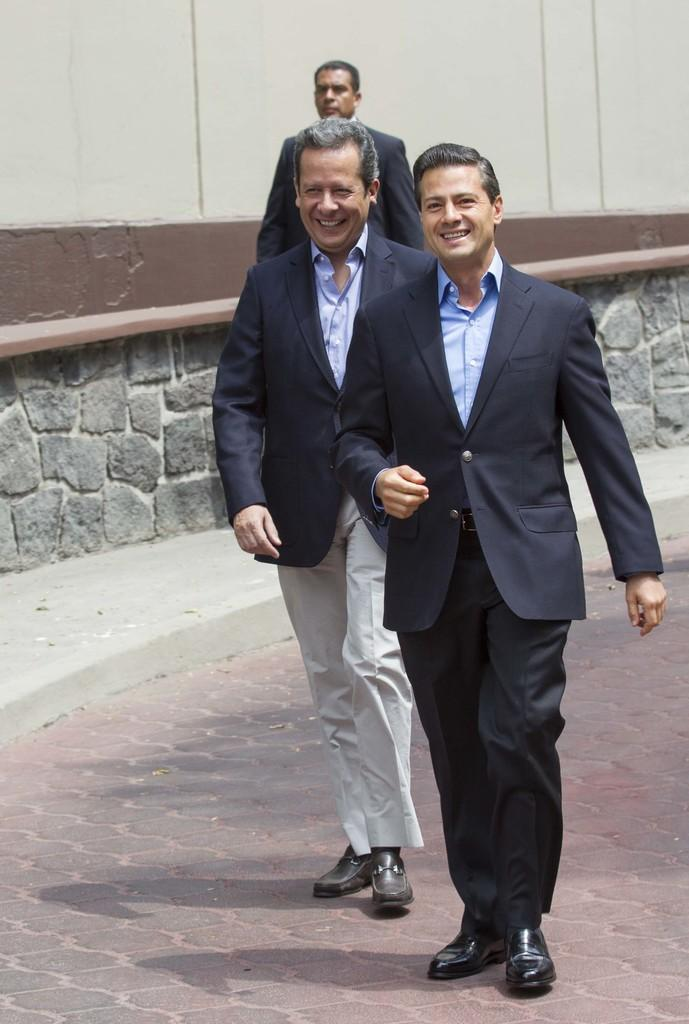How many people are in the image? There are three men in the image. What are the men doing in the image? The men are walking on a road. What can be seen in the background of the image? There is a wall visible in the background of the image. What type of camera can be seen in the hands of one of the men in the image? There is no camera visible in the hands of any of the men in the image. 